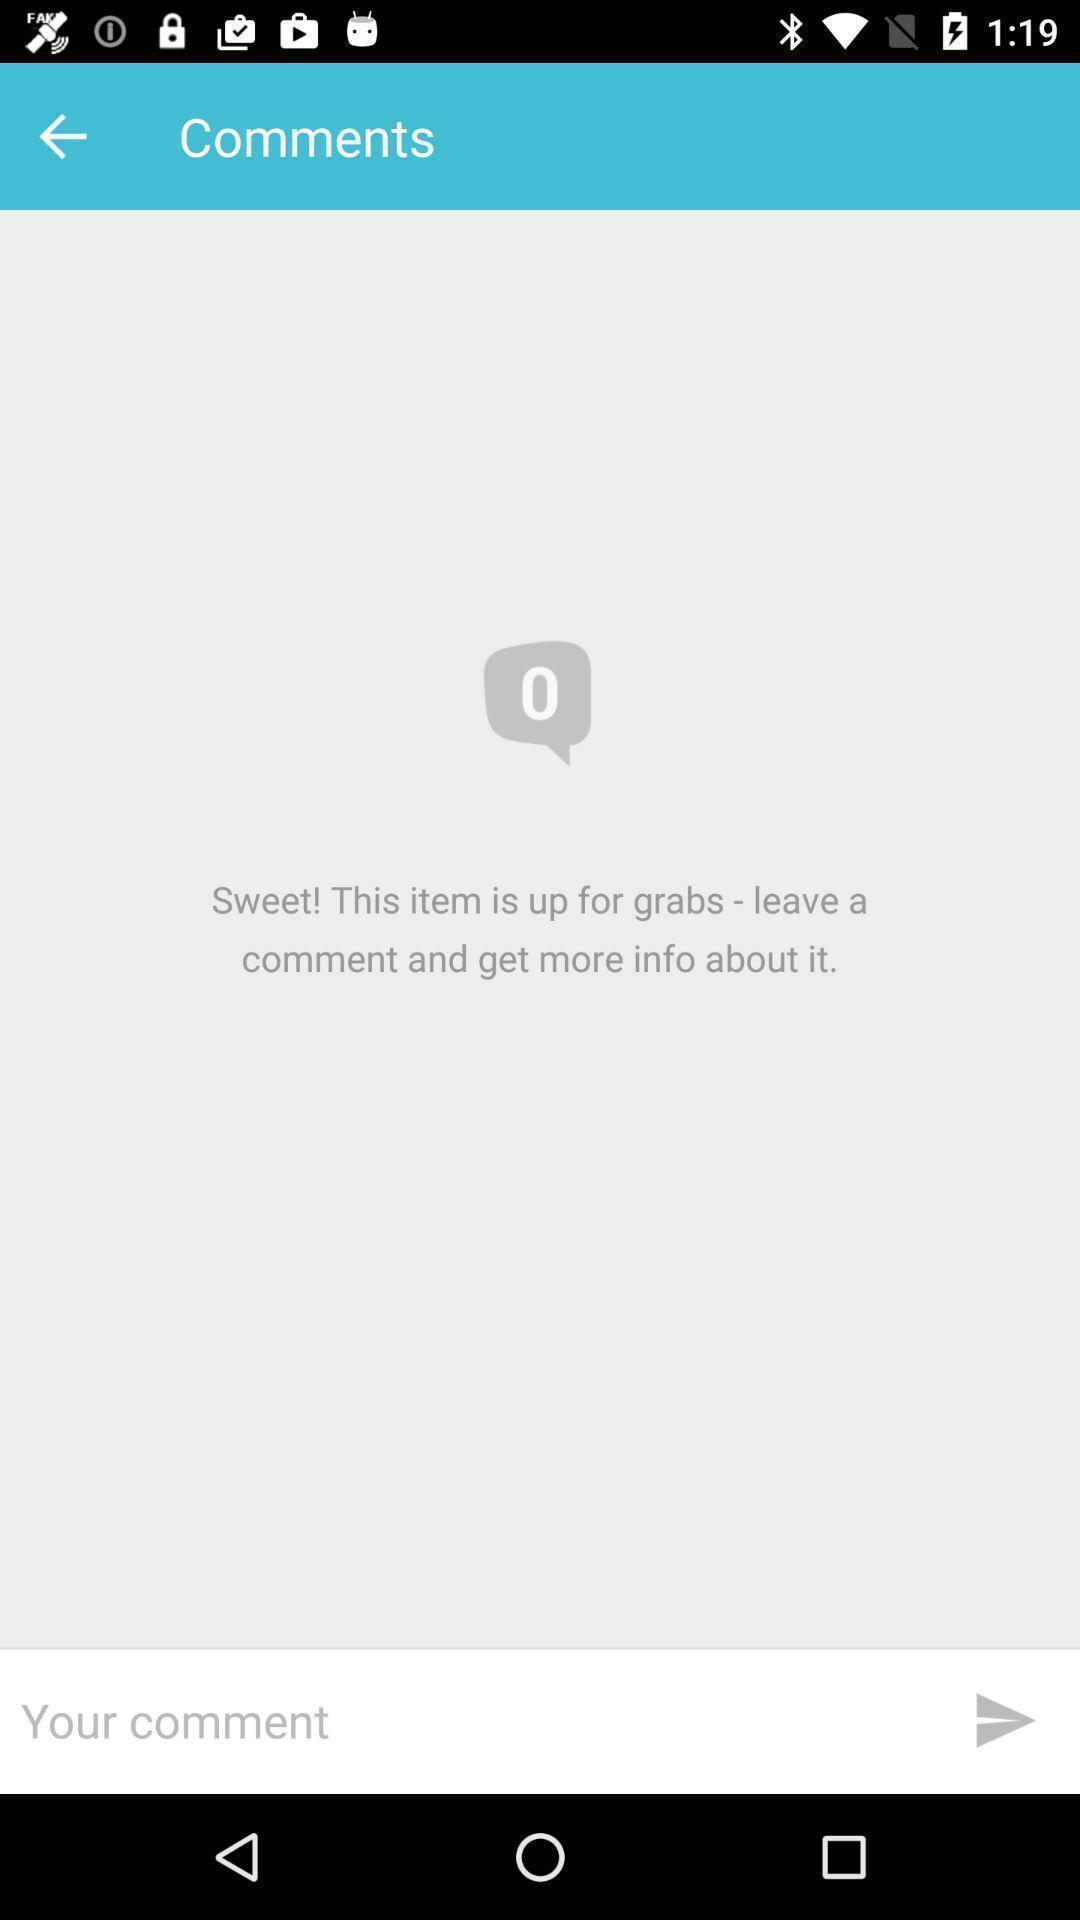Give me a summary of this screen capture. Screen displaying the comments page. 